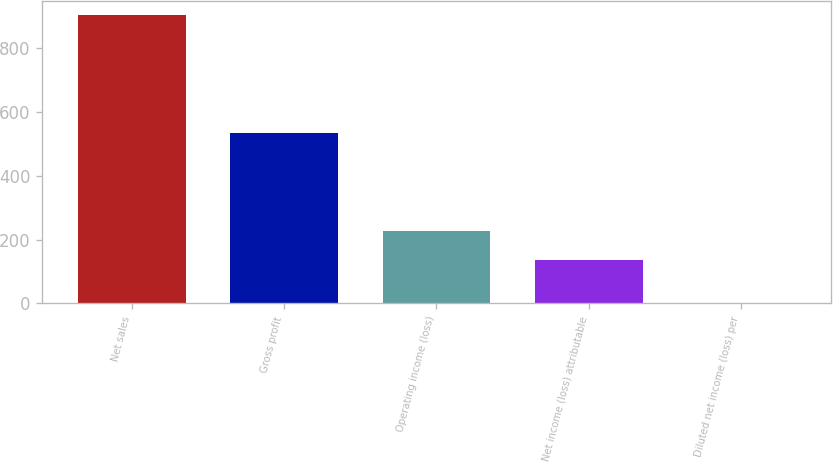Convert chart to OTSL. <chart><loc_0><loc_0><loc_500><loc_500><bar_chart><fcel>Net sales<fcel>Gross profit<fcel>Operating income (loss)<fcel>Net income (loss) attributable<fcel>Diluted net income (loss) per<nl><fcel>902.7<fcel>532.8<fcel>227.11<fcel>136.9<fcel>0.57<nl></chart> 